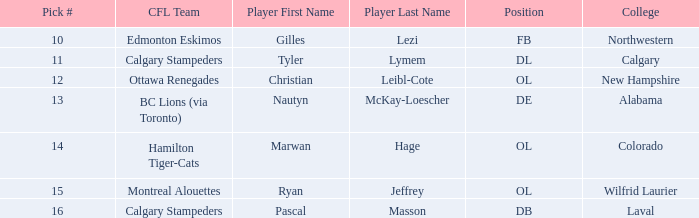What is the pick number for Northwestern college? 10.0. Would you be able to parse every entry in this table? {'header': ['Pick #', 'CFL Team', 'Player First Name', 'Player Last Name', 'Position', 'College'], 'rows': [['10', 'Edmonton Eskimos', 'Gilles', 'Lezi', 'FB', 'Northwestern'], ['11', 'Calgary Stampeders', 'Tyler', 'Lymem', 'DL', 'Calgary'], ['12', 'Ottawa Renegades', 'Christian', 'Leibl-Cote', 'OL', 'New Hampshire'], ['13', 'BC Lions (via Toronto)', 'Nautyn', 'McKay-Loescher', 'DE', 'Alabama'], ['14', 'Hamilton Tiger-Cats', 'Marwan', 'Hage', 'OL', 'Colorado'], ['15', 'Montreal Alouettes', 'Ryan', 'Jeffrey', 'OL', 'Wilfrid Laurier'], ['16', 'Calgary Stampeders', 'Pascal', 'Masson', 'DB', 'Laval']]} 